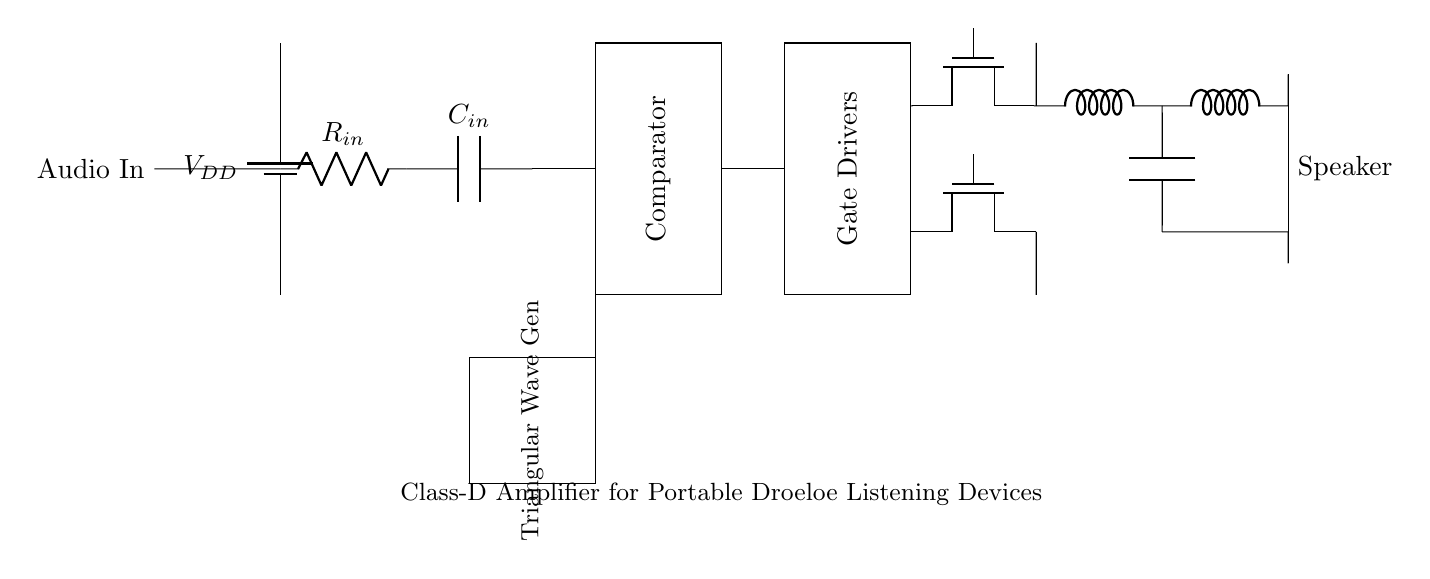What type of amplifier is represented? The circuit diagram displays a Class-D amplifier, which is characterized by its ability to operate using pulse-width modulation, making it suitable for efficient power delivery.
Answer: Class-D What is the role of the triangular wave generator? The triangular wave generator produces a reference waveform that is used by the comparator to compare with the input audio signal. This process helps in modulating the output signal for the amplifier.
Answer: Modulation What component is responsible for driving the MOSFETs? The gate drivers are responsible for providing the appropriate voltage levels to switch the MOSFETs on and off, ensuring efficient amplification of the audio signal.
Answer: Gate drivers Which components form the output filter section? The output filter section consists of an inductor and a capacitor arranged to smooth out the pulse signals generated by the amplifier, resulting in a cleaner audio output to the speaker.
Answer: Inductor and capacitor What is connected at the input of the amplifier? The input of the amplifier is connected to an audio signal source through a resistor and capacitor, which together help to filter and condition the incoming audio signal for amplification.
Answer: Audio signal source How does the Class-D amplifier achieve efficiency? Class-D amplifiers achieve efficiency through pulse-width modulation (PWM), where the output stage operates either fully on or fully off, minimizing power loss during operation.
Answer: Pulse-width modulation What is the function of the LC filter? The LC filter acts to eliminate high-frequency switching artifacts from the output of the amplifier before the signal reaches the speaker, ensuring that only the desired audio frequencies are presented to the load.
Answer: Filtering 